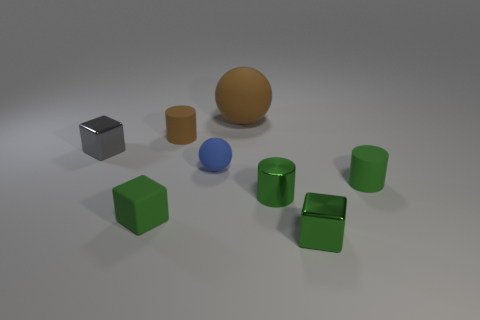Subtract all tiny rubber cylinders. How many cylinders are left? 1 Subtract all yellow balls. How many green cubes are left? 2 Add 1 small brown rubber cylinders. How many objects exist? 9 Subtract all green cylinders. How many cylinders are left? 1 Subtract all cyan cylinders. Subtract all red cubes. How many cylinders are left? 3 Subtract 0 brown cubes. How many objects are left? 8 Subtract all cylinders. How many objects are left? 5 Subtract all large spheres. Subtract all large brown matte objects. How many objects are left? 6 Add 5 tiny shiny cylinders. How many tiny shiny cylinders are left? 6 Add 3 big gray objects. How many big gray objects exist? 3 